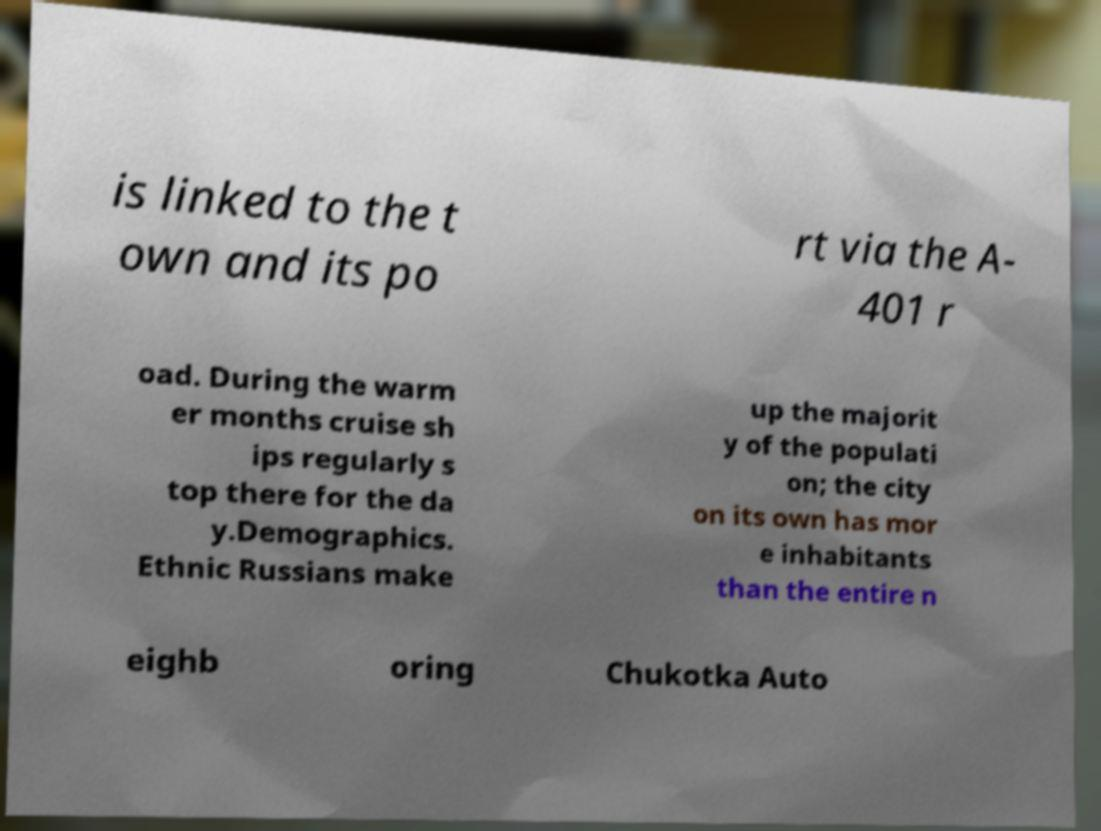Could you assist in decoding the text presented in this image and type it out clearly? is linked to the t own and its po rt via the A- 401 r oad. During the warm er months cruise sh ips regularly s top there for the da y.Demographics. Ethnic Russians make up the majorit y of the populati on; the city on its own has mor e inhabitants than the entire n eighb oring Chukotka Auto 